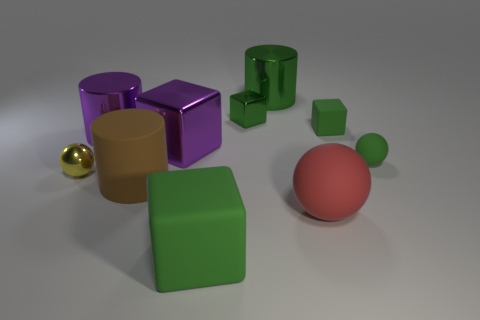Are there any red rubber things left of the tiny sphere that is to the left of the matte thing in front of the big red matte ball?
Keep it short and to the point. No. How many big brown things have the same material as the large green cylinder?
Offer a very short reply. 0. Does the green matte cube that is in front of the yellow metal sphere have the same size as the green rubber block behind the red rubber thing?
Make the answer very short. No. What is the color of the ball that is on the left side of the large brown thing on the left side of the large green metal object that is on the right side of the tiny yellow thing?
Provide a short and direct response. Yellow. Are there any red objects that have the same shape as the large green matte object?
Offer a terse response. No. Are there the same number of yellow objects in front of the large brown rubber thing and yellow balls behind the yellow metal object?
Your answer should be compact. Yes. Do the purple thing that is behind the purple metallic block and the big brown thing have the same shape?
Offer a very short reply. Yes. Is the yellow object the same shape as the brown rubber object?
Keep it short and to the point. No. What number of metal things are either gray spheres or green balls?
Make the answer very short. 0. What is the material of the cylinder that is the same color as the small matte block?
Your answer should be very brief. Metal. 